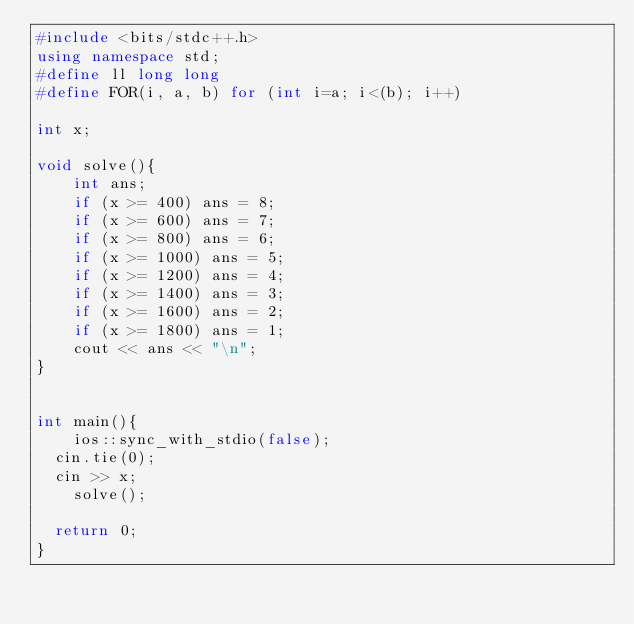Convert code to text. <code><loc_0><loc_0><loc_500><loc_500><_C++_>#include <bits/stdc++.h>
using namespace std;
#define ll long long
#define FOR(i, a, b) for (int i=a; i<(b); i++)

int x;

void solve(){
    int ans;
    if (x >= 400) ans = 8;
    if (x >= 600) ans = 7;
    if (x >= 800) ans = 6;
    if (x >= 1000) ans = 5;
    if (x >= 1200) ans = 4;
    if (x >= 1400) ans = 3;
    if (x >= 1600) ans = 2;
    if (x >= 1800) ans = 1;
    cout << ans << "\n";
}


int main(){
   	ios::sync_with_stdio(false);
	cin.tie(0);
	cin >> x;
    solve();
	
	return 0;
}</code> 